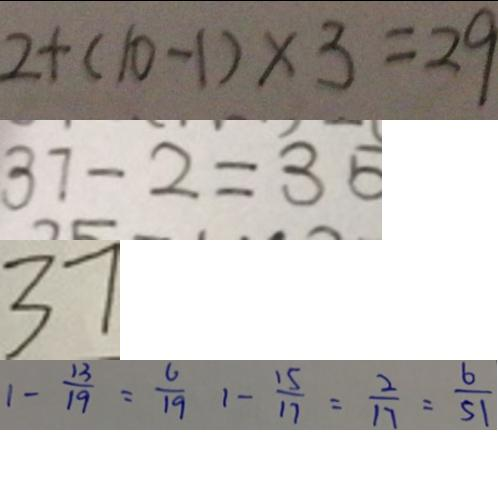<formula> <loc_0><loc_0><loc_500><loc_500>2 + ( 1 0 - 1 ) \times 3 = 2 9 
 3 7 - 2 = 3 5 
 3 7 
 1 - \frac { 1 3 } { 1 9 } = \frac { 6 } { 1 9 } 1 - \frac { 1 5 } { 1 7 } = \frac { 2 } { 1 7 } = \frac { 6 } { 5 1 }</formula> 